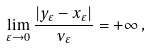Convert formula to latex. <formula><loc_0><loc_0><loc_500><loc_500>\lim _ { \varepsilon \to 0 } \frac { | y _ { \varepsilon } - x _ { \varepsilon } | } { \nu _ { \varepsilon } } = + \infty \, ,</formula> 